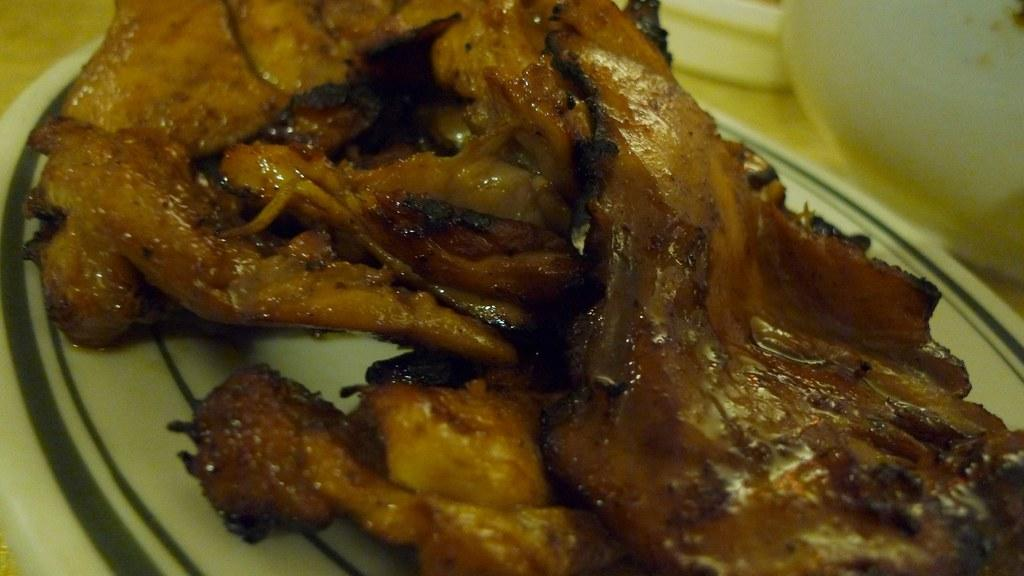What object can be seen in the image that is typically used for serving food? There is a plate in the image. What is on the plate that is being served? There is food present on the plate. What type of book is being used as a plate in the image? There is no book present in the image; it is a plate with food on it. What kind of plant can be seen growing on the plate in the image? There is no plant present on the plate in the image; it is a plate with food on it. 